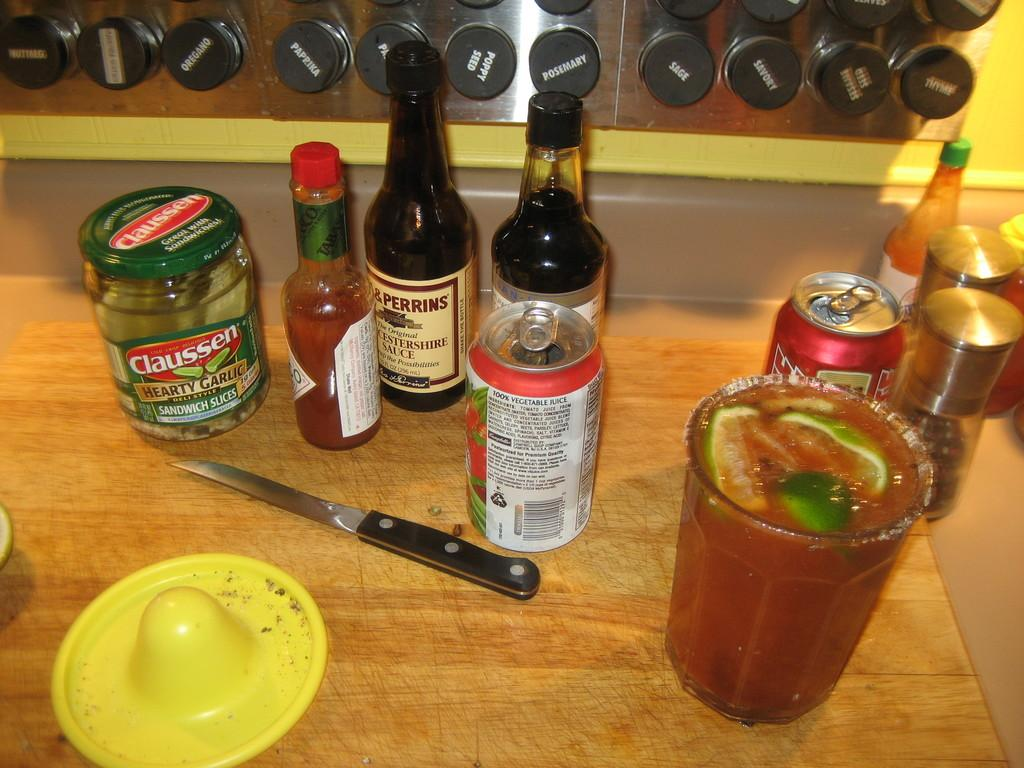<image>
Give a short and clear explanation of the subsequent image. A table with multiple condiments and drinks, contains a jar of Claussen pickles. 